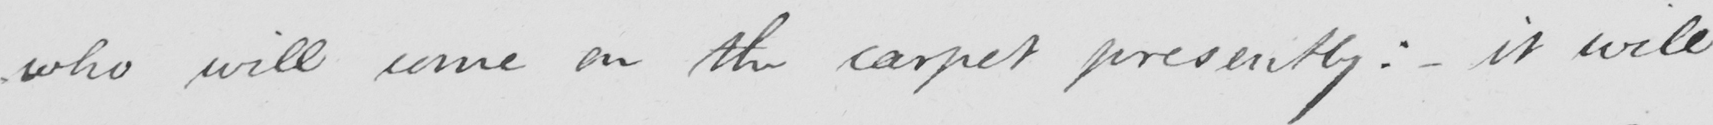Can you read and transcribe this handwriting? who will come on the carpet presently :  - it will 